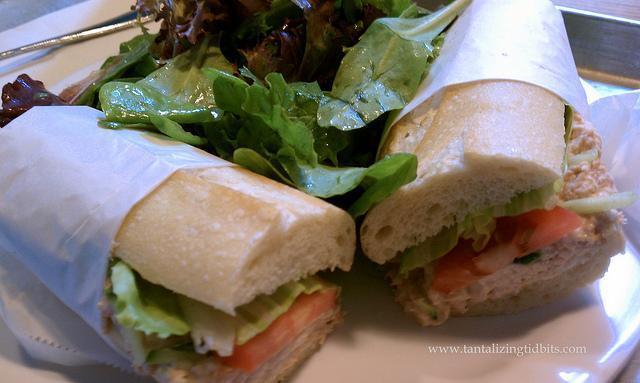What animal will most likely eat this meal?
Indicate the correct response by choosing from the four available options to answer the question.
Options: Elephant, human, bird, cow. Human. 